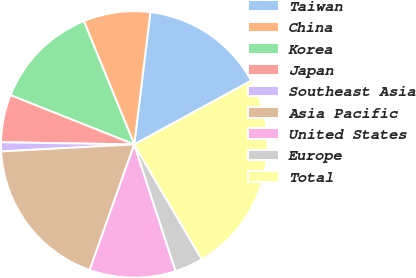<chart> <loc_0><loc_0><loc_500><loc_500><pie_chart><fcel>Taiwan<fcel>China<fcel>Korea<fcel>Japan<fcel>Southeast Asia<fcel>Asia Pacific<fcel>United States<fcel>Europe<fcel>Total<nl><fcel>15.13%<fcel>8.11%<fcel>12.79%<fcel>5.77%<fcel>1.1%<fcel>18.73%<fcel>10.45%<fcel>3.43%<fcel>24.49%<nl></chart> 